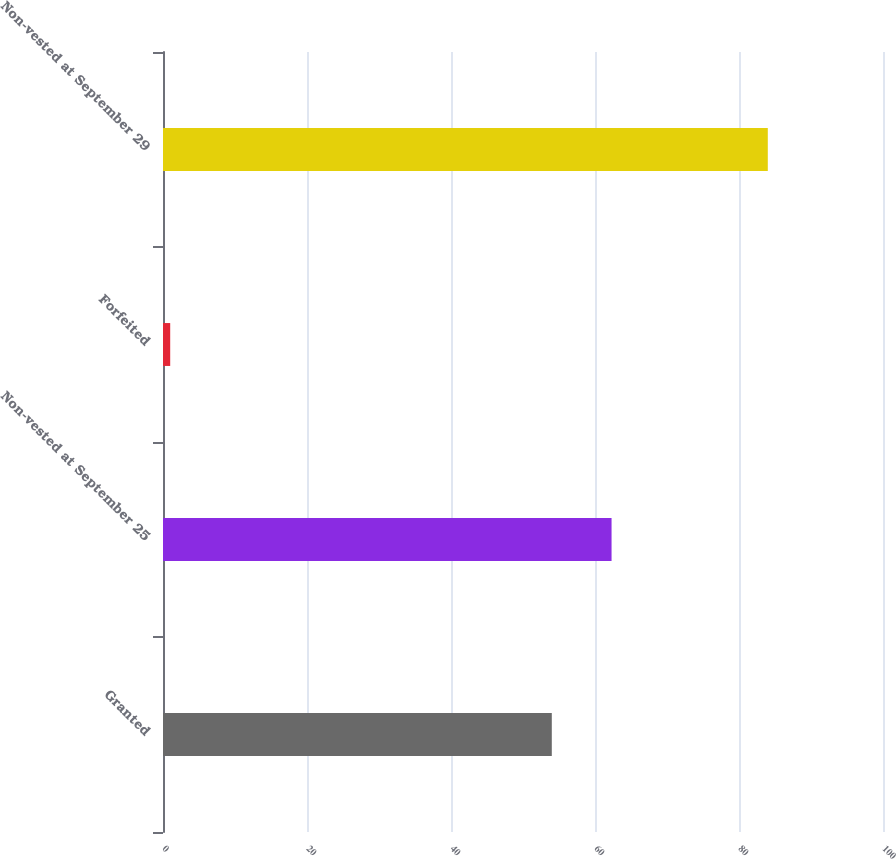<chart> <loc_0><loc_0><loc_500><loc_500><bar_chart><fcel>Granted<fcel>Non-vested at September 25<fcel>Forfeited<fcel>Non-vested at September 29<nl><fcel>54<fcel>62.3<fcel>1<fcel>84<nl></chart> 